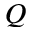<formula> <loc_0><loc_0><loc_500><loc_500>Q</formula> 